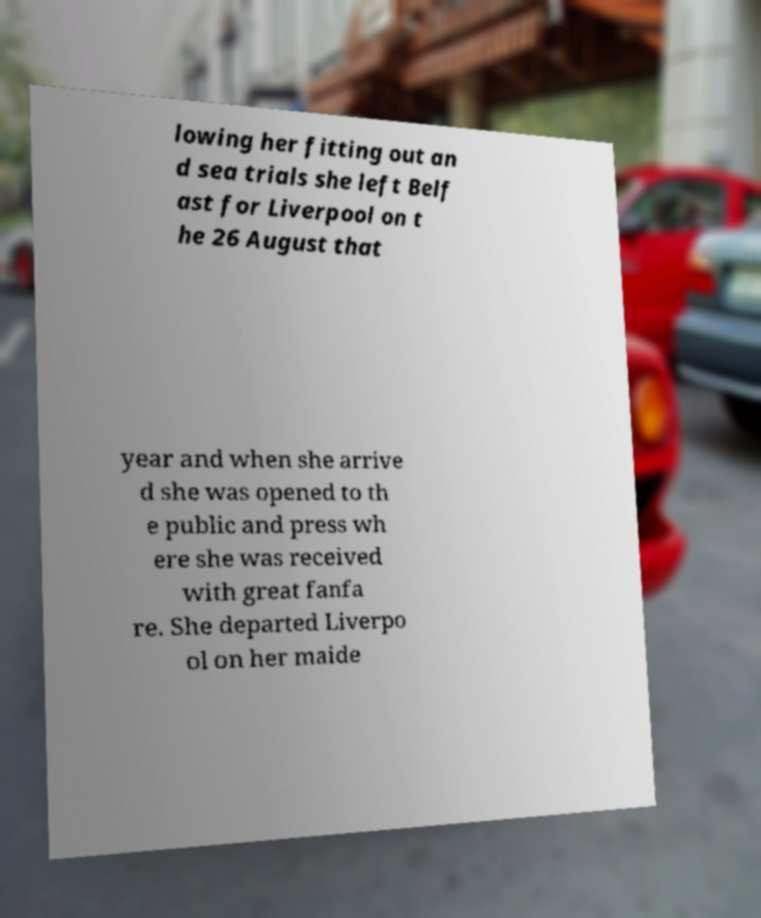For documentation purposes, I need the text within this image transcribed. Could you provide that? lowing her fitting out an d sea trials she left Belf ast for Liverpool on t he 26 August that year and when she arrive d she was opened to th e public and press wh ere she was received with great fanfa re. She departed Liverpo ol on her maide 